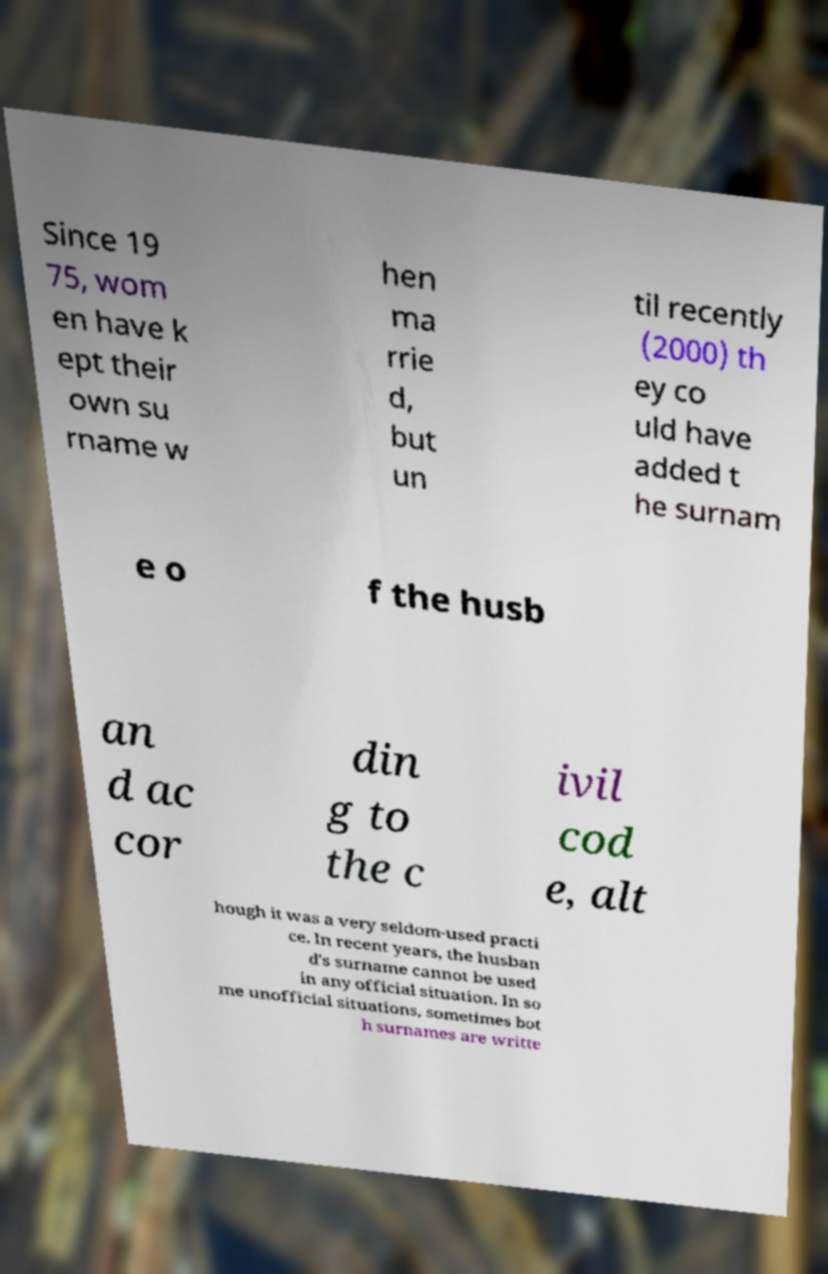I need the written content from this picture converted into text. Can you do that? Since 19 75, wom en have k ept their own su rname w hen ma rrie d, but un til recently (2000) th ey co uld have added t he surnam e o f the husb an d ac cor din g to the c ivil cod e, alt hough it was a very seldom-used practi ce. In recent years, the husban d's surname cannot be used in any official situation. In so me unofficial situations, sometimes bot h surnames are writte 